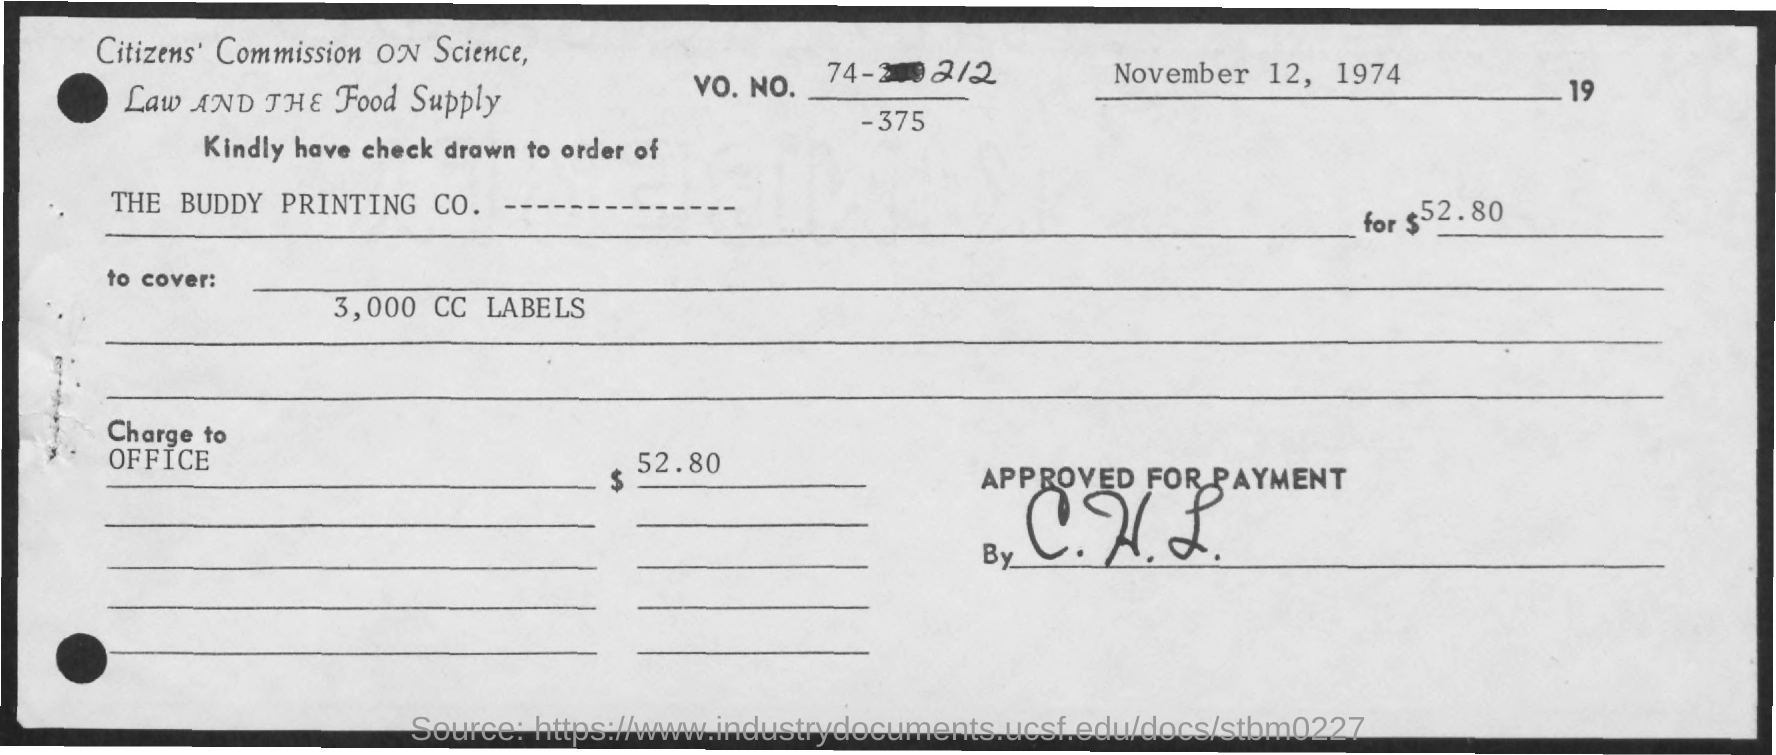Mention a couple of crucial points in this snapshot. The check is being drawn to the order of the Buddy Printing Company. What is the meaning of the phrase "charge to" in the context of an office? The date written on the document is November 12, 1974. The amount is 52.80. The VO. NO. is 74-212. 